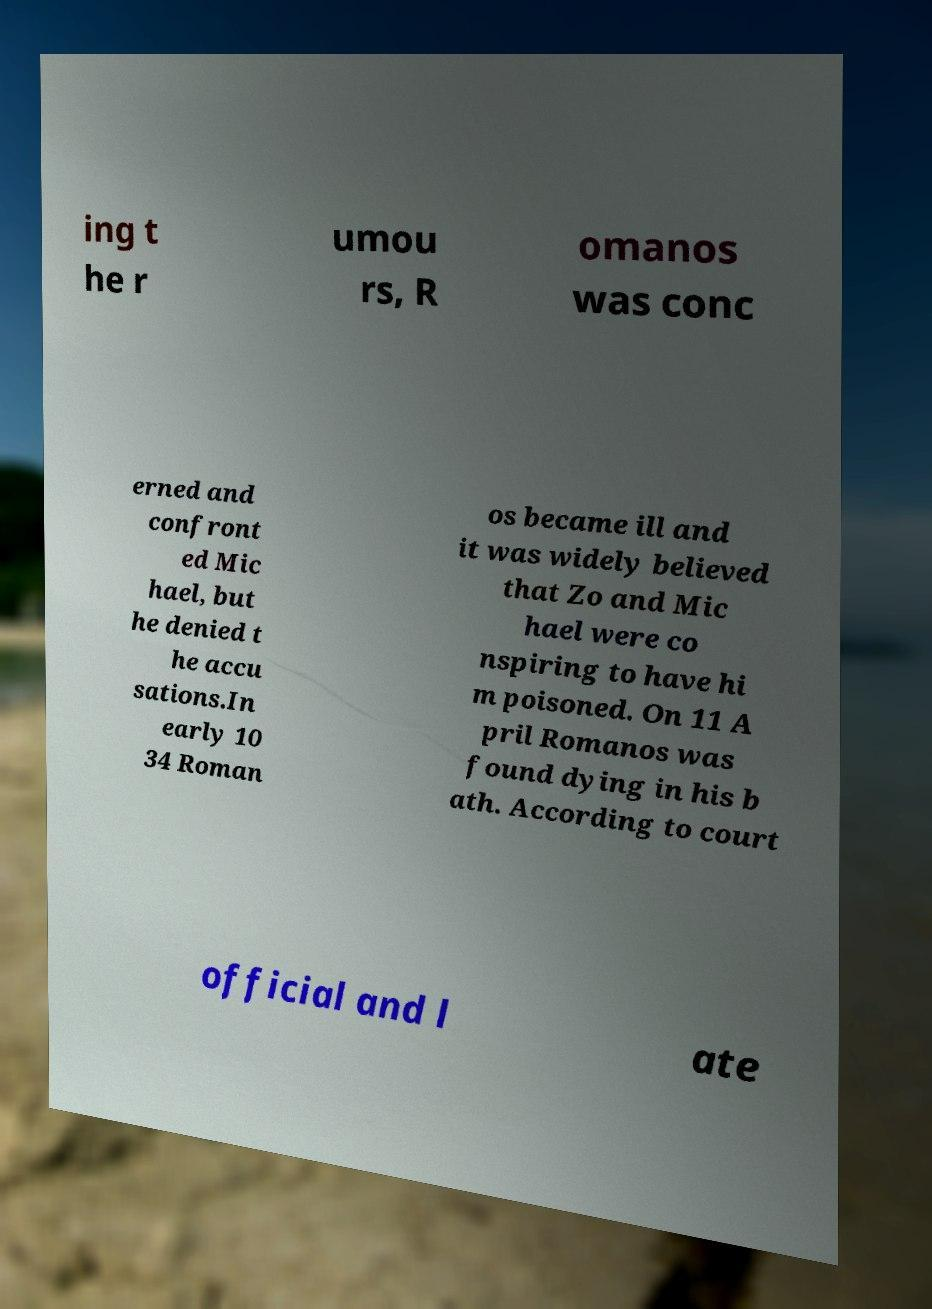Please read and relay the text visible in this image. What does it say? ing t he r umou rs, R omanos was conc erned and confront ed Mic hael, but he denied t he accu sations.In early 10 34 Roman os became ill and it was widely believed that Zo and Mic hael were co nspiring to have hi m poisoned. On 11 A pril Romanos was found dying in his b ath. According to court official and l ate 